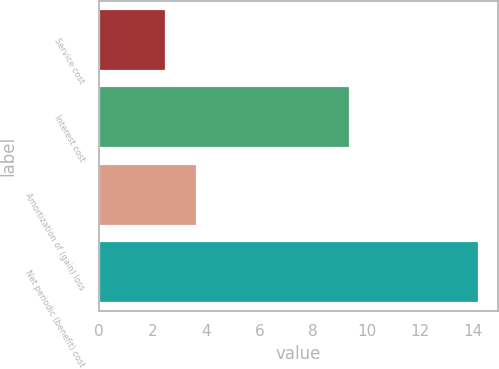Convert chart. <chart><loc_0><loc_0><loc_500><loc_500><bar_chart><fcel>Service cost<fcel>Interest cost<fcel>Amortization of (gain) loss<fcel>Net periodic (benefit) cost<nl><fcel>2.5<fcel>9.4<fcel>3.67<fcel>14.2<nl></chart> 